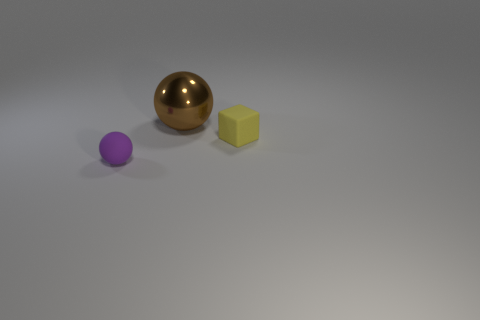Add 2 tiny matte things. How many objects exist? 5 Subtract all spheres. How many objects are left? 1 Subtract all tiny yellow cubes. Subtract all balls. How many objects are left? 0 Add 2 rubber cubes. How many rubber cubes are left? 3 Add 3 large brown metal objects. How many large brown metal objects exist? 4 Subtract 1 yellow cubes. How many objects are left? 2 